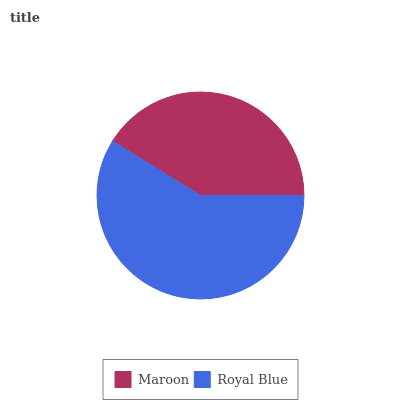Is Maroon the minimum?
Answer yes or no. Yes. Is Royal Blue the maximum?
Answer yes or no. Yes. Is Royal Blue the minimum?
Answer yes or no. No. Is Royal Blue greater than Maroon?
Answer yes or no. Yes. Is Maroon less than Royal Blue?
Answer yes or no. Yes. Is Maroon greater than Royal Blue?
Answer yes or no. No. Is Royal Blue less than Maroon?
Answer yes or no. No. Is Royal Blue the high median?
Answer yes or no. Yes. Is Maroon the low median?
Answer yes or no. Yes. Is Maroon the high median?
Answer yes or no. No. Is Royal Blue the low median?
Answer yes or no. No. 